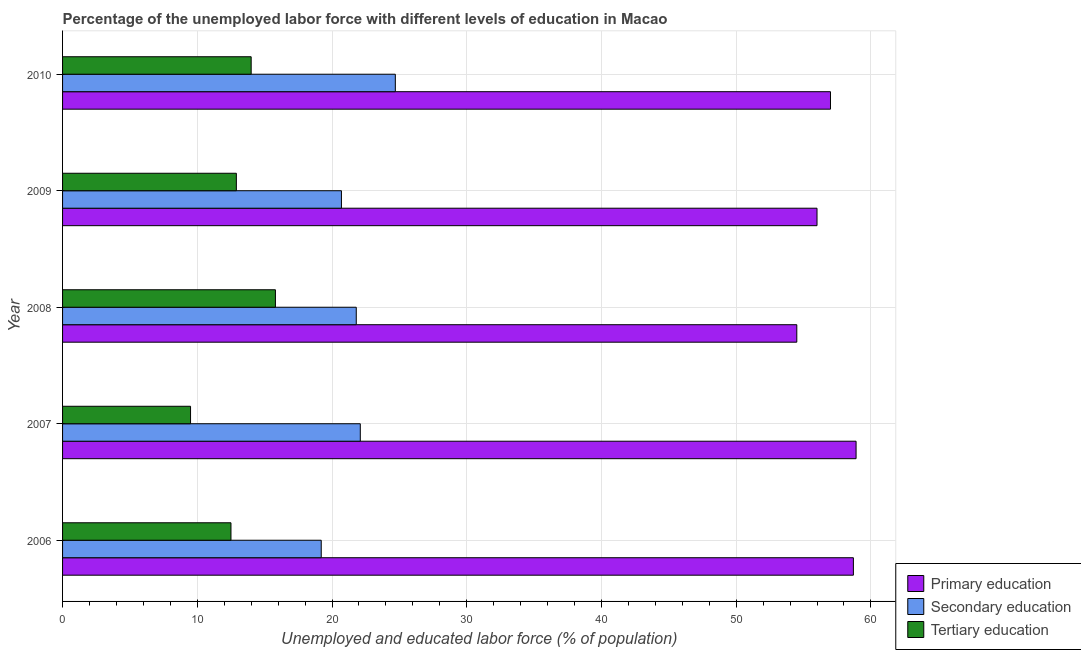How many different coloured bars are there?
Keep it short and to the point. 3. How many groups of bars are there?
Your answer should be very brief. 5. Are the number of bars per tick equal to the number of legend labels?
Provide a succinct answer. Yes. Are the number of bars on each tick of the Y-axis equal?
Your answer should be compact. Yes. How many bars are there on the 3rd tick from the bottom?
Your answer should be very brief. 3. What is the label of the 5th group of bars from the top?
Offer a terse response. 2006. What is the percentage of labor force who received primary education in 2008?
Your answer should be compact. 54.5. Across all years, what is the maximum percentage of labor force who received secondary education?
Make the answer very short. 24.7. Across all years, what is the minimum percentage of labor force who received secondary education?
Provide a short and direct response. 19.2. In which year was the percentage of labor force who received tertiary education maximum?
Your answer should be very brief. 2008. What is the total percentage of labor force who received primary education in the graph?
Provide a short and direct response. 285.1. What is the difference between the percentage of labor force who received secondary education in 2006 and the percentage of labor force who received primary education in 2010?
Your answer should be very brief. -37.8. What is the average percentage of labor force who received secondary education per year?
Keep it short and to the point. 21.7. In the year 2007, what is the difference between the percentage of labor force who received tertiary education and percentage of labor force who received primary education?
Provide a succinct answer. -49.4. What is the ratio of the percentage of labor force who received secondary education in 2008 to that in 2009?
Make the answer very short. 1.05. What is the difference between the highest and the lowest percentage of labor force who received secondary education?
Your response must be concise. 5.5. Is the sum of the percentage of labor force who received secondary education in 2006 and 2010 greater than the maximum percentage of labor force who received primary education across all years?
Provide a short and direct response. No. What does the 2nd bar from the top in 2007 represents?
Your answer should be very brief. Secondary education. Is it the case that in every year, the sum of the percentage of labor force who received primary education and percentage of labor force who received secondary education is greater than the percentage of labor force who received tertiary education?
Provide a short and direct response. Yes. How many bars are there?
Ensure brevity in your answer.  15. What is the difference between two consecutive major ticks on the X-axis?
Give a very brief answer. 10. Are the values on the major ticks of X-axis written in scientific E-notation?
Keep it short and to the point. No. Does the graph contain grids?
Your answer should be very brief. Yes. How many legend labels are there?
Keep it short and to the point. 3. What is the title of the graph?
Your answer should be compact. Percentage of the unemployed labor force with different levels of education in Macao. What is the label or title of the X-axis?
Offer a terse response. Unemployed and educated labor force (% of population). What is the label or title of the Y-axis?
Provide a succinct answer. Year. What is the Unemployed and educated labor force (% of population) of Primary education in 2006?
Your answer should be compact. 58.7. What is the Unemployed and educated labor force (% of population) in Secondary education in 2006?
Provide a succinct answer. 19.2. What is the Unemployed and educated labor force (% of population) of Tertiary education in 2006?
Provide a succinct answer. 12.5. What is the Unemployed and educated labor force (% of population) of Primary education in 2007?
Your answer should be very brief. 58.9. What is the Unemployed and educated labor force (% of population) in Secondary education in 2007?
Keep it short and to the point. 22.1. What is the Unemployed and educated labor force (% of population) in Primary education in 2008?
Offer a terse response. 54.5. What is the Unemployed and educated labor force (% of population) in Secondary education in 2008?
Keep it short and to the point. 21.8. What is the Unemployed and educated labor force (% of population) of Tertiary education in 2008?
Provide a succinct answer. 15.8. What is the Unemployed and educated labor force (% of population) of Secondary education in 2009?
Keep it short and to the point. 20.7. What is the Unemployed and educated labor force (% of population) of Tertiary education in 2009?
Offer a very short reply. 12.9. What is the Unemployed and educated labor force (% of population) of Secondary education in 2010?
Your response must be concise. 24.7. What is the Unemployed and educated labor force (% of population) in Tertiary education in 2010?
Your answer should be very brief. 14. Across all years, what is the maximum Unemployed and educated labor force (% of population) of Primary education?
Provide a succinct answer. 58.9. Across all years, what is the maximum Unemployed and educated labor force (% of population) in Secondary education?
Give a very brief answer. 24.7. Across all years, what is the maximum Unemployed and educated labor force (% of population) of Tertiary education?
Your response must be concise. 15.8. Across all years, what is the minimum Unemployed and educated labor force (% of population) of Primary education?
Keep it short and to the point. 54.5. Across all years, what is the minimum Unemployed and educated labor force (% of population) of Secondary education?
Make the answer very short. 19.2. What is the total Unemployed and educated labor force (% of population) of Primary education in the graph?
Give a very brief answer. 285.1. What is the total Unemployed and educated labor force (% of population) of Secondary education in the graph?
Your answer should be very brief. 108.5. What is the total Unemployed and educated labor force (% of population) of Tertiary education in the graph?
Offer a very short reply. 64.7. What is the difference between the Unemployed and educated labor force (% of population) of Secondary education in 2006 and that in 2007?
Make the answer very short. -2.9. What is the difference between the Unemployed and educated labor force (% of population) in Tertiary education in 2006 and that in 2007?
Give a very brief answer. 3. What is the difference between the Unemployed and educated labor force (% of population) in Primary education in 2006 and that in 2008?
Provide a short and direct response. 4.2. What is the difference between the Unemployed and educated labor force (% of population) of Secondary education in 2006 and that in 2008?
Keep it short and to the point. -2.6. What is the difference between the Unemployed and educated labor force (% of population) of Tertiary education in 2006 and that in 2008?
Offer a very short reply. -3.3. What is the difference between the Unemployed and educated labor force (% of population) in Secondary education in 2006 and that in 2009?
Offer a very short reply. -1.5. What is the difference between the Unemployed and educated labor force (% of population) of Secondary education in 2006 and that in 2010?
Your answer should be compact. -5.5. What is the difference between the Unemployed and educated labor force (% of population) of Tertiary education in 2006 and that in 2010?
Offer a very short reply. -1.5. What is the difference between the Unemployed and educated labor force (% of population) in Secondary education in 2007 and that in 2008?
Your answer should be very brief. 0.3. What is the difference between the Unemployed and educated labor force (% of population) of Secondary education in 2007 and that in 2009?
Offer a terse response. 1.4. What is the difference between the Unemployed and educated labor force (% of population) in Primary education in 2007 and that in 2010?
Offer a very short reply. 1.9. What is the difference between the Unemployed and educated labor force (% of population) of Secondary education in 2007 and that in 2010?
Give a very brief answer. -2.6. What is the difference between the Unemployed and educated labor force (% of population) of Tertiary education in 2008 and that in 2009?
Make the answer very short. 2.9. What is the difference between the Unemployed and educated labor force (% of population) of Secondary education in 2008 and that in 2010?
Offer a terse response. -2.9. What is the difference between the Unemployed and educated labor force (% of population) in Secondary education in 2009 and that in 2010?
Offer a terse response. -4. What is the difference between the Unemployed and educated labor force (% of population) of Primary education in 2006 and the Unemployed and educated labor force (% of population) of Secondary education in 2007?
Provide a short and direct response. 36.6. What is the difference between the Unemployed and educated labor force (% of population) of Primary education in 2006 and the Unemployed and educated labor force (% of population) of Tertiary education in 2007?
Your response must be concise. 49.2. What is the difference between the Unemployed and educated labor force (% of population) of Primary education in 2006 and the Unemployed and educated labor force (% of population) of Secondary education in 2008?
Provide a succinct answer. 36.9. What is the difference between the Unemployed and educated labor force (% of population) in Primary education in 2006 and the Unemployed and educated labor force (% of population) in Tertiary education in 2008?
Give a very brief answer. 42.9. What is the difference between the Unemployed and educated labor force (% of population) in Secondary education in 2006 and the Unemployed and educated labor force (% of population) in Tertiary education in 2008?
Provide a short and direct response. 3.4. What is the difference between the Unemployed and educated labor force (% of population) of Primary education in 2006 and the Unemployed and educated labor force (% of population) of Tertiary education in 2009?
Make the answer very short. 45.8. What is the difference between the Unemployed and educated labor force (% of population) in Primary education in 2006 and the Unemployed and educated labor force (% of population) in Tertiary education in 2010?
Your response must be concise. 44.7. What is the difference between the Unemployed and educated labor force (% of population) of Secondary education in 2006 and the Unemployed and educated labor force (% of population) of Tertiary education in 2010?
Offer a very short reply. 5.2. What is the difference between the Unemployed and educated labor force (% of population) of Primary education in 2007 and the Unemployed and educated labor force (% of population) of Secondary education in 2008?
Provide a short and direct response. 37.1. What is the difference between the Unemployed and educated labor force (% of population) of Primary education in 2007 and the Unemployed and educated labor force (% of population) of Tertiary education in 2008?
Make the answer very short. 43.1. What is the difference between the Unemployed and educated labor force (% of population) of Secondary education in 2007 and the Unemployed and educated labor force (% of population) of Tertiary education in 2008?
Offer a terse response. 6.3. What is the difference between the Unemployed and educated labor force (% of population) of Primary education in 2007 and the Unemployed and educated labor force (% of population) of Secondary education in 2009?
Your answer should be very brief. 38.2. What is the difference between the Unemployed and educated labor force (% of population) of Primary education in 2007 and the Unemployed and educated labor force (% of population) of Secondary education in 2010?
Make the answer very short. 34.2. What is the difference between the Unemployed and educated labor force (% of population) of Primary education in 2007 and the Unemployed and educated labor force (% of population) of Tertiary education in 2010?
Give a very brief answer. 44.9. What is the difference between the Unemployed and educated labor force (% of population) of Primary education in 2008 and the Unemployed and educated labor force (% of population) of Secondary education in 2009?
Offer a very short reply. 33.8. What is the difference between the Unemployed and educated labor force (% of population) of Primary education in 2008 and the Unemployed and educated labor force (% of population) of Tertiary education in 2009?
Provide a short and direct response. 41.6. What is the difference between the Unemployed and educated labor force (% of population) of Primary education in 2008 and the Unemployed and educated labor force (% of population) of Secondary education in 2010?
Your answer should be compact. 29.8. What is the difference between the Unemployed and educated labor force (% of population) in Primary education in 2008 and the Unemployed and educated labor force (% of population) in Tertiary education in 2010?
Make the answer very short. 40.5. What is the difference between the Unemployed and educated labor force (% of population) in Secondary education in 2008 and the Unemployed and educated labor force (% of population) in Tertiary education in 2010?
Your answer should be compact. 7.8. What is the difference between the Unemployed and educated labor force (% of population) in Primary education in 2009 and the Unemployed and educated labor force (% of population) in Secondary education in 2010?
Your answer should be compact. 31.3. What is the difference between the Unemployed and educated labor force (% of population) of Primary education in 2009 and the Unemployed and educated labor force (% of population) of Tertiary education in 2010?
Provide a short and direct response. 42. What is the difference between the Unemployed and educated labor force (% of population) of Secondary education in 2009 and the Unemployed and educated labor force (% of population) of Tertiary education in 2010?
Provide a short and direct response. 6.7. What is the average Unemployed and educated labor force (% of population) in Primary education per year?
Keep it short and to the point. 57.02. What is the average Unemployed and educated labor force (% of population) of Secondary education per year?
Make the answer very short. 21.7. What is the average Unemployed and educated labor force (% of population) of Tertiary education per year?
Make the answer very short. 12.94. In the year 2006, what is the difference between the Unemployed and educated labor force (% of population) in Primary education and Unemployed and educated labor force (% of population) in Secondary education?
Keep it short and to the point. 39.5. In the year 2006, what is the difference between the Unemployed and educated labor force (% of population) of Primary education and Unemployed and educated labor force (% of population) of Tertiary education?
Your answer should be very brief. 46.2. In the year 2007, what is the difference between the Unemployed and educated labor force (% of population) in Primary education and Unemployed and educated labor force (% of population) in Secondary education?
Your answer should be compact. 36.8. In the year 2007, what is the difference between the Unemployed and educated labor force (% of population) of Primary education and Unemployed and educated labor force (% of population) of Tertiary education?
Ensure brevity in your answer.  49.4. In the year 2008, what is the difference between the Unemployed and educated labor force (% of population) in Primary education and Unemployed and educated labor force (% of population) in Secondary education?
Make the answer very short. 32.7. In the year 2008, what is the difference between the Unemployed and educated labor force (% of population) in Primary education and Unemployed and educated labor force (% of population) in Tertiary education?
Your answer should be very brief. 38.7. In the year 2009, what is the difference between the Unemployed and educated labor force (% of population) in Primary education and Unemployed and educated labor force (% of population) in Secondary education?
Your answer should be compact. 35.3. In the year 2009, what is the difference between the Unemployed and educated labor force (% of population) of Primary education and Unemployed and educated labor force (% of population) of Tertiary education?
Your response must be concise. 43.1. In the year 2010, what is the difference between the Unemployed and educated labor force (% of population) in Primary education and Unemployed and educated labor force (% of population) in Secondary education?
Make the answer very short. 32.3. In the year 2010, what is the difference between the Unemployed and educated labor force (% of population) in Secondary education and Unemployed and educated labor force (% of population) in Tertiary education?
Provide a succinct answer. 10.7. What is the ratio of the Unemployed and educated labor force (% of population) in Secondary education in 2006 to that in 2007?
Offer a very short reply. 0.87. What is the ratio of the Unemployed and educated labor force (% of population) in Tertiary education in 2006 to that in 2007?
Give a very brief answer. 1.32. What is the ratio of the Unemployed and educated labor force (% of population) in Primary education in 2006 to that in 2008?
Ensure brevity in your answer.  1.08. What is the ratio of the Unemployed and educated labor force (% of population) in Secondary education in 2006 to that in 2008?
Your answer should be very brief. 0.88. What is the ratio of the Unemployed and educated labor force (% of population) in Tertiary education in 2006 to that in 2008?
Offer a terse response. 0.79. What is the ratio of the Unemployed and educated labor force (% of population) in Primary education in 2006 to that in 2009?
Ensure brevity in your answer.  1.05. What is the ratio of the Unemployed and educated labor force (% of population) of Secondary education in 2006 to that in 2009?
Your answer should be very brief. 0.93. What is the ratio of the Unemployed and educated labor force (% of population) of Primary education in 2006 to that in 2010?
Make the answer very short. 1.03. What is the ratio of the Unemployed and educated labor force (% of population) in Secondary education in 2006 to that in 2010?
Keep it short and to the point. 0.78. What is the ratio of the Unemployed and educated labor force (% of population) in Tertiary education in 2006 to that in 2010?
Offer a very short reply. 0.89. What is the ratio of the Unemployed and educated labor force (% of population) in Primary education in 2007 to that in 2008?
Offer a very short reply. 1.08. What is the ratio of the Unemployed and educated labor force (% of population) of Secondary education in 2007 to that in 2008?
Offer a terse response. 1.01. What is the ratio of the Unemployed and educated labor force (% of population) of Tertiary education in 2007 to that in 2008?
Keep it short and to the point. 0.6. What is the ratio of the Unemployed and educated labor force (% of population) in Primary education in 2007 to that in 2009?
Provide a succinct answer. 1.05. What is the ratio of the Unemployed and educated labor force (% of population) in Secondary education in 2007 to that in 2009?
Offer a very short reply. 1.07. What is the ratio of the Unemployed and educated labor force (% of population) in Tertiary education in 2007 to that in 2009?
Give a very brief answer. 0.74. What is the ratio of the Unemployed and educated labor force (% of population) in Secondary education in 2007 to that in 2010?
Offer a very short reply. 0.89. What is the ratio of the Unemployed and educated labor force (% of population) in Tertiary education in 2007 to that in 2010?
Your answer should be very brief. 0.68. What is the ratio of the Unemployed and educated labor force (% of population) in Primary education in 2008 to that in 2009?
Your answer should be very brief. 0.97. What is the ratio of the Unemployed and educated labor force (% of population) in Secondary education in 2008 to that in 2009?
Offer a terse response. 1.05. What is the ratio of the Unemployed and educated labor force (% of population) in Tertiary education in 2008 to that in 2009?
Provide a short and direct response. 1.22. What is the ratio of the Unemployed and educated labor force (% of population) in Primary education in 2008 to that in 2010?
Offer a terse response. 0.96. What is the ratio of the Unemployed and educated labor force (% of population) of Secondary education in 2008 to that in 2010?
Give a very brief answer. 0.88. What is the ratio of the Unemployed and educated labor force (% of population) of Tertiary education in 2008 to that in 2010?
Your answer should be very brief. 1.13. What is the ratio of the Unemployed and educated labor force (% of population) in Primary education in 2009 to that in 2010?
Ensure brevity in your answer.  0.98. What is the ratio of the Unemployed and educated labor force (% of population) of Secondary education in 2009 to that in 2010?
Give a very brief answer. 0.84. What is the ratio of the Unemployed and educated labor force (% of population) of Tertiary education in 2009 to that in 2010?
Offer a terse response. 0.92. What is the difference between the highest and the lowest Unemployed and educated labor force (% of population) of Primary education?
Offer a very short reply. 4.4. What is the difference between the highest and the lowest Unemployed and educated labor force (% of population) of Tertiary education?
Your answer should be compact. 6.3. 